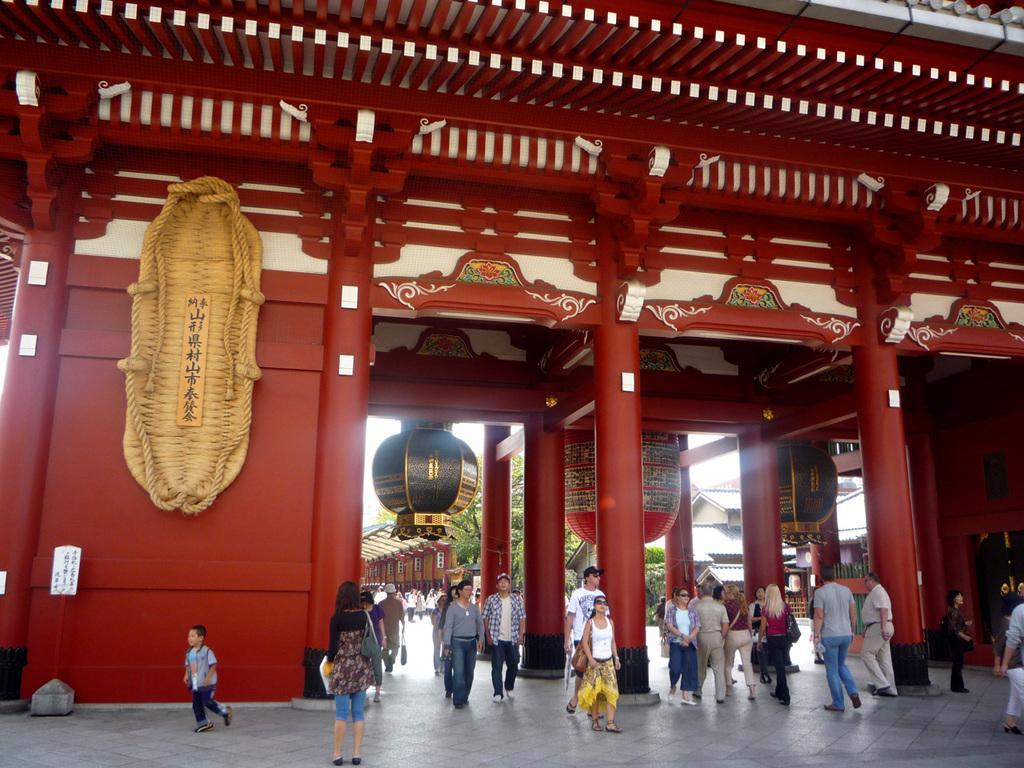Describe this image in one or two sentences. In this picture we can see a few people, pillars, some text on the boards and a few objects. We can see some leaves and houses. 